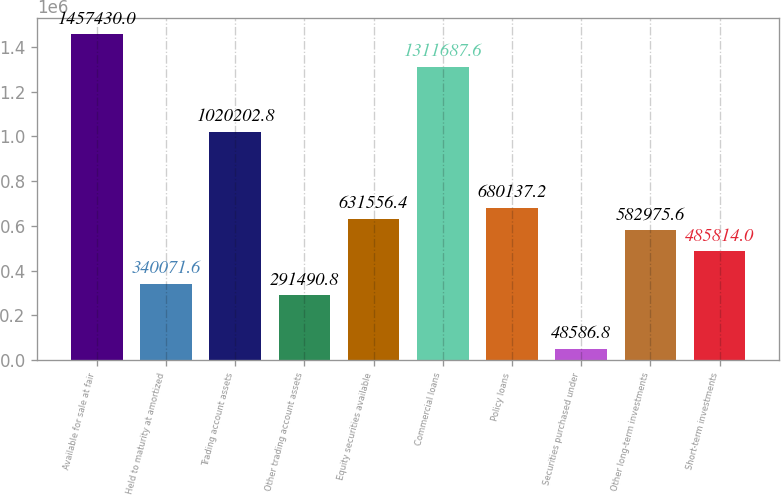Convert chart to OTSL. <chart><loc_0><loc_0><loc_500><loc_500><bar_chart><fcel>Available for sale at fair<fcel>Held to maturity at amortized<fcel>Trading account assets<fcel>Other trading account assets<fcel>Equity securities available<fcel>Commercial loans<fcel>Policy loans<fcel>Securities purchased under<fcel>Other long-term investments<fcel>Short-term investments<nl><fcel>1.45743e+06<fcel>340072<fcel>1.0202e+06<fcel>291491<fcel>631556<fcel>1.31169e+06<fcel>680137<fcel>48586.8<fcel>582976<fcel>485814<nl></chart> 